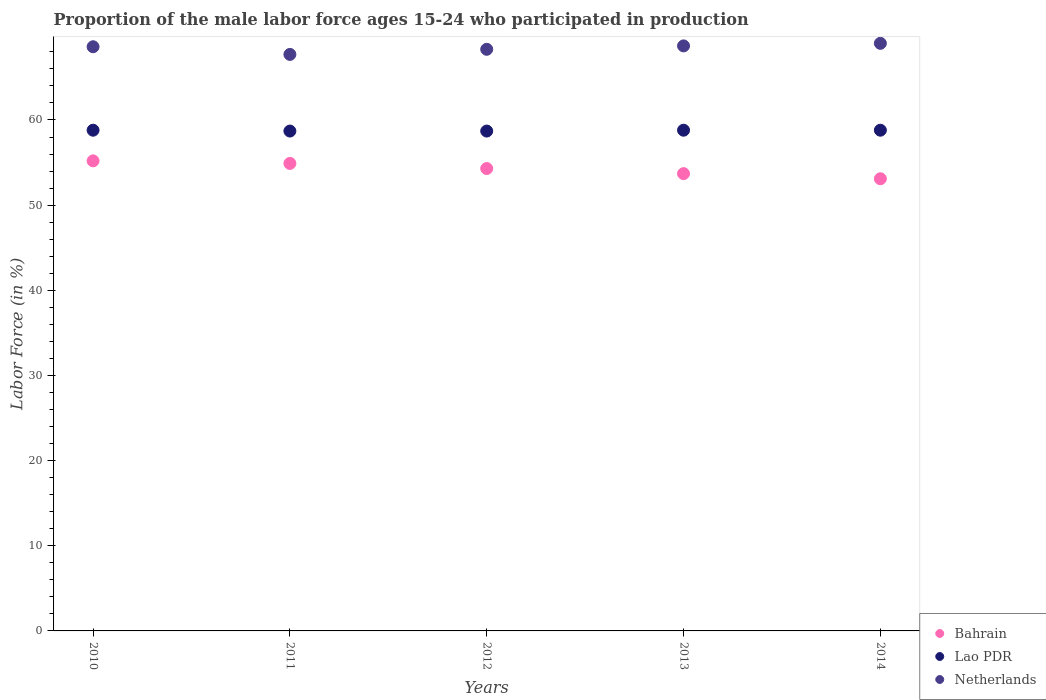How many different coloured dotlines are there?
Make the answer very short. 3. Is the number of dotlines equal to the number of legend labels?
Give a very brief answer. Yes. What is the proportion of the male labor force who participated in production in Bahrain in 2011?
Ensure brevity in your answer.  54.9. Across all years, what is the maximum proportion of the male labor force who participated in production in Netherlands?
Ensure brevity in your answer.  69. Across all years, what is the minimum proportion of the male labor force who participated in production in Netherlands?
Your response must be concise. 67.7. In which year was the proportion of the male labor force who participated in production in Lao PDR maximum?
Make the answer very short. 2010. What is the total proportion of the male labor force who participated in production in Bahrain in the graph?
Provide a short and direct response. 271.2. What is the difference between the proportion of the male labor force who participated in production in Netherlands in 2012 and that in 2013?
Provide a succinct answer. -0.4. What is the difference between the proportion of the male labor force who participated in production in Netherlands in 2013 and the proportion of the male labor force who participated in production in Bahrain in 2010?
Your answer should be very brief. 13.5. What is the average proportion of the male labor force who participated in production in Lao PDR per year?
Ensure brevity in your answer.  58.76. In the year 2014, what is the difference between the proportion of the male labor force who participated in production in Lao PDR and proportion of the male labor force who participated in production in Netherlands?
Make the answer very short. -10.2. In how many years, is the proportion of the male labor force who participated in production in Netherlands greater than 2 %?
Provide a short and direct response. 5. What is the ratio of the proportion of the male labor force who participated in production in Netherlands in 2012 to that in 2013?
Your response must be concise. 0.99. Is the difference between the proportion of the male labor force who participated in production in Lao PDR in 2010 and 2013 greater than the difference between the proportion of the male labor force who participated in production in Netherlands in 2010 and 2013?
Offer a terse response. Yes. What is the difference between the highest and the second highest proportion of the male labor force who participated in production in Bahrain?
Provide a succinct answer. 0.3. What is the difference between the highest and the lowest proportion of the male labor force who participated in production in Lao PDR?
Your answer should be very brief. 0.1. Does the proportion of the male labor force who participated in production in Bahrain monotonically increase over the years?
Your answer should be compact. No. Is the proportion of the male labor force who participated in production in Bahrain strictly less than the proportion of the male labor force who participated in production in Lao PDR over the years?
Ensure brevity in your answer.  Yes. How many years are there in the graph?
Your answer should be compact. 5. Are the values on the major ticks of Y-axis written in scientific E-notation?
Provide a succinct answer. No. Does the graph contain any zero values?
Offer a very short reply. No. Where does the legend appear in the graph?
Keep it short and to the point. Bottom right. How many legend labels are there?
Provide a short and direct response. 3. What is the title of the graph?
Your response must be concise. Proportion of the male labor force ages 15-24 who participated in production. What is the label or title of the Y-axis?
Your response must be concise. Labor Force (in %). What is the Labor Force (in %) of Bahrain in 2010?
Your answer should be compact. 55.2. What is the Labor Force (in %) in Lao PDR in 2010?
Your answer should be compact. 58.8. What is the Labor Force (in %) of Netherlands in 2010?
Make the answer very short. 68.6. What is the Labor Force (in %) in Bahrain in 2011?
Offer a terse response. 54.9. What is the Labor Force (in %) in Lao PDR in 2011?
Provide a succinct answer. 58.7. What is the Labor Force (in %) of Netherlands in 2011?
Your answer should be very brief. 67.7. What is the Labor Force (in %) in Bahrain in 2012?
Your answer should be compact. 54.3. What is the Labor Force (in %) of Lao PDR in 2012?
Give a very brief answer. 58.7. What is the Labor Force (in %) of Netherlands in 2012?
Give a very brief answer. 68.3. What is the Labor Force (in %) of Bahrain in 2013?
Give a very brief answer. 53.7. What is the Labor Force (in %) of Lao PDR in 2013?
Give a very brief answer. 58.8. What is the Labor Force (in %) in Netherlands in 2013?
Your response must be concise. 68.7. What is the Labor Force (in %) in Bahrain in 2014?
Your answer should be compact. 53.1. What is the Labor Force (in %) in Lao PDR in 2014?
Your response must be concise. 58.8. Across all years, what is the maximum Labor Force (in %) in Bahrain?
Keep it short and to the point. 55.2. Across all years, what is the maximum Labor Force (in %) in Lao PDR?
Ensure brevity in your answer.  58.8. Across all years, what is the minimum Labor Force (in %) of Bahrain?
Offer a very short reply. 53.1. Across all years, what is the minimum Labor Force (in %) of Lao PDR?
Your answer should be very brief. 58.7. Across all years, what is the minimum Labor Force (in %) of Netherlands?
Provide a succinct answer. 67.7. What is the total Labor Force (in %) of Bahrain in the graph?
Provide a succinct answer. 271.2. What is the total Labor Force (in %) of Lao PDR in the graph?
Your response must be concise. 293.8. What is the total Labor Force (in %) in Netherlands in the graph?
Ensure brevity in your answer.  342.3. What is the difference between the Labor Force (in %) of Bahrain in 2010 and that in 2011?
Make the answer very short. 0.3. What is the difference between the Labor Force (in %) in Netherlands in 2010 and that in 2011?
Offer a very short reply. 0.9. What is the difference between the Labor Force (in %) of Lao PDR in 2010 and that in 2013?
Offer a terse response. 0. What is the difference between the Labor Force (in %) of Bahrain in 2010 and that in 2014?
Your response must be concise. 2.1. What is the difference between the Labor Force (in %) in Lao PDR in 2010 and that in 2014?
Offer a very short reply. 0. What is the difference between the Labor Force (in %) of Netherlands in 2010 and that in 2014?
Provide a short and direct response. -0.4. What is the difference between the Labor Force (in %) in Bahrain in 2011 and that in 2012?
Keep it short and to the point. 0.6. What is the difference between the Labor Force (in %) in Lao PDR in 2011 and that in 2012?
Ensure brevity in your answer.  0. What is the difference between the Labor Force (in %) of Bahrain in 2011 and that in 2013?
Offer a very short reply. 1.2. What is the difference between the Labor Force (in %) in Lao PDR in 2011 and that in 2013?
Keep it short and to the point. -0.1. What is the difference between the Labor Force (in %) in Lao PDR in 2011 and that in 2014?
Your answer should be very brief. -0.1. What is the difference between the Labor Force (in %) in Netherlands in 2011 and that in 2014?
Provide a short and direct response. -1.3. What is the difference between the Labor Force (in %) in Bahrain in 2012 and that in 2013?
Your answer should be compact. 0.6. What is the difference between the Labor Force (in %) in Lao PDR in 2012 and that in 2013?
Your answer should be very brief. -0.1. What is the difference between the Labor Force (in %) in Netherlands in 2012 and that in 2014?
Your answer should be compact. -0.7. What is the difference between the Labor Force (in %) in Bahrain in 2013 and that in 2014?
Your response must be concise. 0.6. What is the difference between the Labor Force (in %) of Bahrain in 2010 and the Labor Force (in %) of Lao PDR in 2012?
Make the answer very short. -3.5. What is the difference between the Labor Force (in %) of Bahrain in 2010 and the Labor Force (in %) of Netherlands in 2012?
Offer a terse response. -13.1. What is the difference between the Labor Force (in %) of Lao PDR in 2010 and the Labor Force (in %) of Netherlands in 2012?
Make the answer very short. -9.5. What is the difference between the Labor Force (in %) of Bahrain in 2010 and the Labor Force (in %) of Netherlands in 2013?
Your answer should be compact. -13.5. What is the difference between the Labor Force (in %) in Lao PDR in 2010 and the Labor Force (in %) in Netherlands in 2013?
Your answer should be very brief. -9.9. What is the difference between the Labor Force (in %) in Bahrain in 2010 and the Labor Force (in %) in Netherlands in 2014?
Offer a terse response. -13.8. What is the difference between the Labor Force (in %) in Lao PDR in 2010 and the Labor Force (in %) in Netherlands in 2014?
Offer a very short reply. -10.2. What is the difference between the Labor Force (in %) of Bahrain in 2011 and the Labor Force (in %) of Lao PDR in 2012?
Your answer should be compact. -3.8. What is the difference between the Labor Force (in %) of Bahrain in 2011 and the Labor Force (in %) of Netherlands in 2012?
Provide a short and direct response. -13.4. What is the difference between the Labor Force (in %) in Bahrain in 2011 and the Labor Force (in %) in Netherlands in 2014?
Provide a succinct answer. -14.1. What is the difference between the Labor Force (in %) in Bahrain in 2012 and the Labor Force (in %) in Lao PDR in 2013?
Ensure brevity in your answer.  -4.5. What is the difference between the Labor Force (in %) in Bahrain in 2012 and the Labor Force (in %) in Netherlands in 2013?
Offer a terse response. -14.4. What is the difference between the Labor Force (in %) in Bahrain in 2012 and the Labor Force (in %) in Lao PDR in 2014?
Provide a succinct answer. -4.5. What is the difference between the Labor Force (in %) of Bahrain in 2012 and the Labor Force (in %) of Netherlands in 2014?
Your answer should be very brief. -14.7. What is the difference between the Labor Force (in %) of Lao PDR in 2012 and the Labor Force (in %) of Netherlands in 2014?
Offer a terse response. -10.3. What is the difference between the Labor Force (in %) in Bahrain in 2013 and the Labor Force (in %) in Netherlands in 2014?
Offer a terse response. -15.3. What is the average Labor Force (in %) of Bahrain per year?
Your answer should be very brief. 54.24. What is the average Labor Force (in %) in Lao PDR per year?
Make the answer very short. 58.76. What is the average Labor Force (in %) in Netherlands per year?
Give a very brief answer. 68.46. In the year 2010, what is the difference between the Labor Force (in %) of Lao PDR and Labor Force (in %) of Netherlands?
Make the answer very short. -9.8. In the year 2011, what is the difference between the Labor Force (in %) of Bahrain and Labor Force (in %) of Lao PDR?
Keep it short and to the point. -3.8. In the year 2012, what is the difference between the Labor Force (in %) in Bahrain and Labor Force (in %) in Lao PDR?
Offer a terse response. -4.4. In the year 2012, what is the difference between the Labor Force (in %) of Bahrain and Labor Force (in %) of Netherlands?
Keep it short and to the point. -14. In the year 2012, what is the difference between the Labor Force (in %) of Lao PDR and Labor Force (in %) of Netherlands?
Ensure brevity in your answer.  -9.6. In the year 2013, what is the difference between the Labor Force (in %) in Lao PDR and Labor Force (in %) in Netherlands?
Your response must be concise. -9.9. In the year 2014, what is the difference between the Labor Force (in %) of Bahrain and Labor Force (in %) of Lao PDR?
Keep it short and to the point. -5.7. In the year 2014, what is the difference between the Labor Force (in %) of Bahrain and Labor Force (in %) of Netherlands?
Your answer should be compact. -15.9. In the year 2014, what is the difference between the Labor Force (in %) of Lao PDR and Labor Force (in %) of Netherlands?
Your answer should be compact. -10.2. What is the ratio of the Labor Force (in %) in Lao PDR in 2010 to that in 2011?
Offer a very short reply. 1. What is the ratio of the Labor Force (in %) in Netherlands in 2010 to that in 2011?
Your answer should be compact. 1.01. What is the ratio of the Labor Force (in %) of Bahrain in 2010 to that in 2012?
Provide a short and direct response. 1.02. What is the ratio of the Labor Force (in %) in Netherlands in 2010 to that in 2012?
Make the answer very short. 1. What is the ratio of the Labor Force (in %) in Bahrain in 2010 to that in 2013?
Give a very brief answer. 1.03. What is the ratio of the Labor Force (in %) in Netherlands in 2010 to that in 2013?
Your answer should be compact. 1. What is the ratio of the Labor Force (in %) in Bahrain in 2010 to that in 2014?
Keep it short and to the point. 1.04. What is the ratio of the Labor Force (in %) in Lao PDR in 2010 to that in 2014?
Provide a short and direct response. 1. What is the ratio of the Labor Force (in %) of Bahrain in 2011 to that in 2012?
Provide a short and direct response. 1.01. What is the ratio of the Labor Force (in %) of Lao PDR in 2011 to that in 2012?
Keep it short and to the point. 1. What is the ratio of the Labor Force (in %) of Bahrain in 2011 to that in 2013?
Your answer should be compact. 1.02. What is the ratio of the Labor Force (in %) in Netherlands in 2011 to that in 2013?
Your response must be concise. 0.99. What is the ratio of the Labor Force (in %) of Bahrain in 2011 to that in 2014?
Provide a succinct answer. 1.03. What is the ratio of the Labor Force (in %) of Netherlands in 2011 to that in 2014?
Your response must be concise. 0.98. What is the ratio of the Labor Force (in %) in Bahrain in 2012 to that in 2013?
Your response must be concise. 1.01. What is the ratio of the Labor Force (in %) of Bahrain in 2012 to that in 2014?
Offer a very short reply. 1.02. What is the ratio of the Labor Force (in %) in Bahrain in 2013 to that in 2014?
Your answer should be very brief. 1.01. What is the ratio of the Labor Force (in %) of Netherlands in 2013 to that in 2014?
Give a very brief answer. 1. What is the difference between the highest and the second highest Labor Force (in %) of Lao PDR?
Offer a terse response. 0. What is the difference between the highest and the second highest Labor Force (in %) of Netherlands?
Ensure brevity in your answer.  0.3. What is the difference between the highest and the lowest Labor Force (in %) in Lao PDR?
Ensure brevity in your answer.  0.1. What is the difference between the highest and the lowest Labor Force (in %) of Netherlands?
Provide a succinct answer. 1.3. 